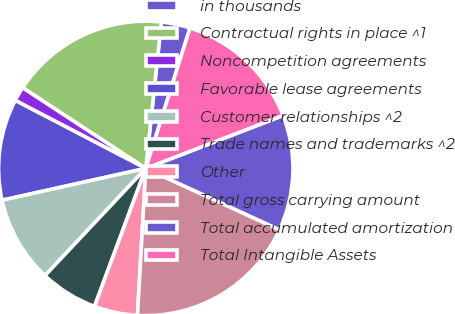Convert chart. <chart><loc_0><loc_0><loc_500><loc_500><pie_chart><fcel>in thousands<fcel>Contractual rights in place ^1<fcel>Noncompetition agreements<fcel>Favorable lease agreements<fcel>Customer relationships ^2<fcel>Trade names and trademarks ^2<fcel>Other<fcel>Total gross carrying amount<fcel>Total accumulated amortization<fcel>Total Intangible Assets<nl><fcel>3.17%<fcel>17.46%<fcel>1.59%<fcel>11.11%<fcel>9.52%<fcel>6.35%<fcel>4.76%<fcel>19.05%<fcel>12.7%<fcel>14.29%<nl></chart> 